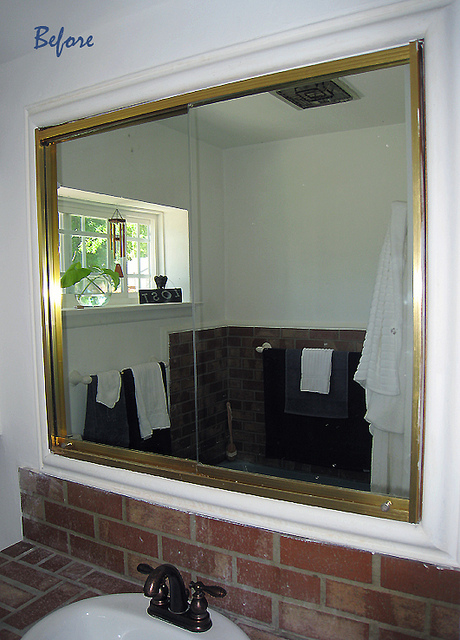Identify and read out the text in this image. Before 